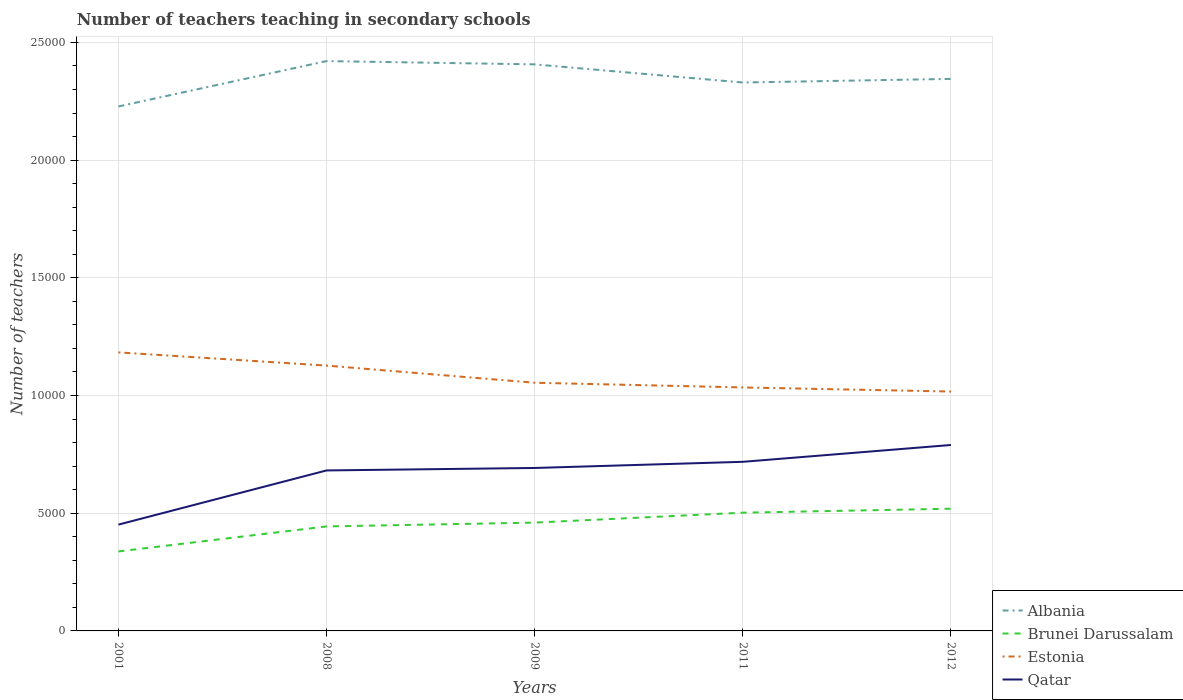How many different coloured lines are there?
Ensure brevity in your answer.  4. Does the line corresponding to Albania intersect with the line corresponding to Qatar?
Provide a short and direct response. No. Is the number of lines equal to the number of legend labels?
Your response must be concise. Yes. Across all years, what is the maximum number of teachers teaching in secondary schools in Brunei Darussalam?
Make the answer very short. 3377. What is the total number of teachers teaching in secondary schools in Qatar in the graph?
Provide a succinct answer. -366. What is the difference between the highest and the second highest number of teachers teaching in secondary schools in Brunei Darussalam?
Your response must be concise. 1815. Is the number of teachers teaching in secondary schools in Estonia strictly greater than the number of teachers teaching in secondary schools in Qatar over the years?
Give a very brief answer. No. How many years are there in the graph?
Your response must be concise. 5. What is the difference between two consecutive major ticks on the Y-axis?
Your answer should be compact. 5000. Are the values on the major ticks of Y-axis written in scientific E-notation?
Provide a short and direct response. No. Does the graph contain any zero values?
Give a very brief answer. No. What is the title of the graph?
Offer a terse response. Number of teachers teaching in secondary schools. Does "Marshall Islands" appear as one of the legend labels in the graph?
Your answer should be very brief. No. What is the label or title of the X-axis?
Ensure brevity in your answer.  Years. What is the label or title of the Y-axis?
Give a very brief answer. Number of teachers. What is the Number of teachers of Albania in 2001?
Offer a very short reply. 2.23e+04. What is the Number of teachers in Brunei Darussalam in 2001?
Provide a short and direct response. 3377. What is the Number of teachers in Estonia in 2001?
Provide a short and direct response. 1.18e+04. What is the Number of teachers in Qatar in 2001?
Your response must be concise. 4516. What is the Number of teachers in Albania in 2008?
Provide a succinct answer. 2.42e+04. What is the Number of teachers of Brunei Darussalam in 2008?
Your response must be concise. 4439. What is the Number of teachers in Estonia in 2008?
Provide a short and direct response. 1.13e+04. What is the Number of teachers in Qatar in 2008?
Provide a short and direct response. 6818. What is the Number of teachers in Albania in 2009?
Ensure brevity in your answer.  2.41e+04. What is the Number of teachers of Brunei Darussalam in 2009?
Offer a terse response. 4601. What is the Number of teachers in Estonia in 2009?
Your answer should be compact. 1.05e+04. What is the Number of teachers in Qatar in 2009?
Offer a very short reply. 6923. What is the Number of teachers in Albania in 2011?
Offer a terse response. 2.33e+04. What is the Number of teachers in Brunei Darussalam in 2011?
Provide a succinct answer. 5023. What is the Number of teachers of Estonia in 2011?
Make the answer very short. 1.03e+04. What is the Number of teachers in Qatar in 2011?
Ensure brevity in your answer.  7184. What is the Number of teachers of Albania in 2012?
Ensure brevity in your answer.  2.35e+04. What is the Number of teachers in Brunei Darussalam in 2012?
Provide a succinct answer. 5192. What is the Number of teachers in Estonia in 2012?
Your answer should be compact. 1.02e+04. What is the Number of teachers in Qatar in 2012?
Provide a short and direct response. 7899. Across all years, what is the maximum Number of teachers of Albania?
Make the answer very short. 2.42e+04. Across all years, what is the maximum Number of teachers in Brunei Darussalam?
Provide a succinct answer. 5192. Across all years, what is the maximum Number of teachers of Estonia?
Make the answer very short. 1.18e+04. Across all years, what is the maximum Number of teachers of Qatar?
Your answer should be compact. 7899. Across all years, what is the minimum Number of teachers of Albania?
Make the answer very short. 2.23e+04. Across all years, what is the minimum Number of teachers of Brunei Darussalam?
Keep it short and to the point. 3377. Across all years, what is the minimum Number of teachers of Estonia?
Keep it short and to the point. 1.02e+04. Across all years, what is the minimum Number of teachers in Qatar?
Provide a succinct answer. 4516. What is the total Number of teachers in Albania in the graph?
Offer a very short reply. 1.17e+05. What is the total Number of teachers of Brunei Darussalam in the graph?
Your answer should be compact. 2.26e+04. What is the total Number of teachers of Estonia in the graph?
Give a very brief answer. 5.42e+04. What is the total Number of teachers in Qatar in the graph?
Your answer should be very brief. 3.33e+04. What is the difference between the Number of teachers in Albania in 2001 and that in 2008?
Keep it short and to the point. -1928. What is the difference between the Number of teachers in Brunei Darussalam in 2001 and that in 2008?
Make the answer very short. -1062. What is the difference between the Number of teachers of Estonia in 2001 and that in 2008?
Ensure brevity in your answer.  561. What is the difference between the Number of teachers in Qatar in 2001 and that in 2008?
Make the answer very short. -2302. What is the difference between the Number of teachers in Albania in 2001 and that in 2009?
Give a very brief answer. -1789. What is the difference between the Number of teachers in Brunei Darussalam in 2001 and that in 2009?
Your response must be concise. -1224. What is the difference between the Number of teachers in Estonia in 2001 and that in 2009?
Provide a succinct answer. 1290. What is the difference between the Number of teachers in Qatar in 2001 and that in 2009?
Provide a short and direct response. -2407. What is the difference between the Number of teachers of Albania in 2001 and that in 2011?
Your answer should be compact. -1018. What is the difference between the Number of teachers of Brunei Darussalam in 2001 and that in 2011?
Your answer should be compact. -1646. What is the difference between the Number of teachers in Estonia in 2001 and that in 2011?
Provide a succinct answer. 1489. What is the difference between the Number of teachers in Qatar in 2001 and that in 2011?
Ensure brevity in your answer.  -2668. What is the difference between the Number of teachers in Albania in 2001 and that in 2012?
Keep it short and to the point. -1172. What is the difference between the Number of teachers of Brunei Darussalam in 2001 and that in 2012?
Provide a succinct answer. -1815. What is the difference between the Number of teachers of Estonia in 2001 and that in 2012?
Give a very brief answer. 1663. What is the difference between the Number of teachers of Qatar in 2001 and that in 2012?
Offer a very short reply. -3383. What is the difference between the Number of teachers in Albania in 2008 and that in 2009?
Give a very brief answer. 139. What is the difference between the Number of teachers in Brunei Darussalam in 2008 and that in 2009?
Provide a succinct answer. -162. What is the difference between the Number of teachers of Estonia in 2008 and that in 2009?
Keep it short and to the point. 729. What is the difference between the Number of teachers of Qatar in 2008 and that in 2009?
Provide a short and direct response. -105. What is the difference between the Number of teachers in Albania in 2008 and that in 2011?
Provide a short and direct response. 910. What is the difference between the Number of teachers in Brunei Darussalam in 2008 and that in 2011?
Your answer should be very brief. -584. What is the difference between the Number of teachers of Estonia in 2008 and that in 2011?
Your response must be concise. 928. What is the difference between the Number of teachers of Qatar in 2008 and that in 2011?
Your answer should be compact. -366. What is the difference between the Number of teachers in Albania in 2008 and that in 2012?
Give a very brief answer. 756. What is the difference between the Number of teachers of Brunei Darussalam in 2008 and that in 2012?
Offer a terse response. -753. What is the difference between the Number of teachers of Estonia in 2008 and that in 2012?
Keep it short and to the point. 1102. What is the difference between the Number of teachers of Qatar in 2008 and that in 2012?
Your answer should be compact. -1081. What is the difference between the Number of teachers of Albania in 2009 and that in 2011?
Offer a very short reply. 771. What is the difference between the Number of teachers in Brunei Darussalam in 2009 and that in 2011?
Make the answer very short. -422. What is the difference between the Number of teachers in Estonia in 2009 and that in 2011?
Give a very brief answer. 199. What is the difference between the Number of teachers of Qatar in 2009 and that in 2011?
Your answer should be compact. -261. What is the difference between the Number of teachers of Albania in 2009 and that in 2012?
Your answer should be very brief. 617. What is the difference between the Number of teachers of Brunei Darussalam in 2009 and that in 2012?
Provide a short and direct response. -591. What is the difference between the Number of teachers in Estonia in 2009 and that in 2012?
Ensure brevity in your answer.  373. What is the difference between the Number of teachers in Qatar in 2009 and that in 2012?
Your answer should be very brief. -976. What is the difference between the Number of teachers in Albania in 2011 and that in 2012?
Provide a short and direct response. -154. What is the difference between the Number of teachers of Brunei Darussalam in 2011 and that in 2012?
Offer a very short reply. -169. What is the difference between the Number of teachers in Estonia in 2011 and that in 2012?
Provide a short and direct response. 174. What is the difference between the Number of teachers of Qatar in 2011 and that in 2012?
Your answer should be compact. -715. What is the difference between the Number of teachers of Albania in 2001 and the Number of teachers of Brunei Darussalam in 2008?
Keep it short and to the point. 1.78e+04. What is the difference between the Number of teachers of Albania in 2001 and the Number of teachers of Estonia in 2008?
Your answer should be very brief. 1.10e+04. What is the difference between the Number of teachers of Albania in 2001 and the Number of teachers of Qatar in 2008?
Offer a terse response. 1.55e+04. What is the difference between the Number of teachers in Brunei Darussalam in 2001 and the Number of teachers in Estonia in 2008?
Offer a very short reply. -7895. What is the difference between the Number of teachers in Brunei Darussalam in 2001 and the Number of teachers in Qatar in 2008?
Provide a short and direct response. -3441. What is the difference between the Number of teachers in Estonia in 2001 and the Number of teachers in Qatar in 2008?
Provide a succinct answer. 5015. What is the difference between the Number of teachers in Albania in 2001 and the Number of teachers in Brunei Darussalam in 2009?
Your response must be concise. 1.77e+04. What is the difference between the Number of teachers in Albania in 2001 and the Number of teachers in Estonia in 2009?
Ensure brevity in your answer.  1.17e+04. What is the difference between the Number of teachers in Albania in 2001 and the Number of teachers in Qatar in 2009?
Ensure brevity in your answer.  1.54e+04. What is the difference between the Number of teachers in Brunei Darussalam in 2001 and the Number of teachers in Estonia in 2009?
Provide a succinct answer. -7166. What is the difference between the Number of teachers of Brunei Darussalam in 2001 and the Number of teachers of Qatar in 2009?
Make the answer very short. -3546. What is the difference between the Number of teachers of Estonia in 2001 and the Number of teachers of Qatar in 2009?
Provide a short and direct response. 4910. What is the difference between the Number of teachers in Albania in 2001 and the Number of teachers in Brunei Darussalam in 2011?
Offer a terse response. 1.73e+04. What is the difference between the Number of teachers in Albania in 2001 and the Number of teachers in Estonia in 2011?
Your response must be concise. 1.19e+04. What is the difference between the Number of teachers of Albania in 2001 and the Number of teachers of Qatar in 2011?
Your response must be concise. 1.51e+04. What is the difference between the Number of teachers of Brunei Darussalam in 2001 and the Number of teachers of Estonia in 2011?
Make the answer very short. -6967. What is the difference between the Number of teachers of Brunei Darussalam in 2001 and the Number of teachers of Qatar in 2011?
Make the answer very short. -3807. What is the difference between the Number of teachers in Estonia in 2001 and the Number of teachers in Qatar in 2011?
Give a very brief answer. 4649. What is the difference between the Number of teachers in Albania in 2001 and the Number of teachers in Brunei Darussalam in 2012?
Provide a succinct answer. 1.71e+04. What is the difference between the Number of teachers in Albania in 2001 and the Number of teachers in Estonia in 2012?
Provide a short and direct response. 1.21e+04. What is the difference between the Number of teachers in Albania in 2001 and the Number of teachers in Qatar in 2012?
Make the answer very short. 1.44e+04. What is the difference between the Number of teachers in Brunei Darussalam in 2001 and the Number of teachers in Estonia in 2012?
Provide a short and direct response. -6793. What is the difference between the Number of teachers of Brunei Darussalam in 2001 and the Number of teachers of Qatar in 2012?
Offer a terse response. -4522. What is the difference between the Number of teachers of Estonia in 2001 and the Number of teachers of Qatar in 2012?
Your response must be concise. 3934. What is the difference between the Number of teachers of Albania in 2008 and the Number of teachers of Brunei Darussalam in 2009?
Your answer should be compact. 1.96e+04. What is the difference between the Number of teachers of Albania in 2008 and the Number of teachers of Estonia in 2009?
Provide a succinct answer. 1.37e+04. What is the difference between the Number of teachers in Albania in 2008 and the Number of teachers in Qatar in 2009?
Offer a very short reply. 1.73e+04. What is the difference between the Number of teachers of Brunei Darussalam in 2008 and the Number of teachers of Estonia in 2009?
Ensure brevity in your answer.  -6104. What is the difference between the Number of teachers in Brunei Darussalam in 2008 and the Number of teachers in Qatar in 2009?
Your answer should be compact. -2484. What is the difference between the Number of teachers in Estonia in 2008 and the Number of teachers in Qatar in 2009?
Make the answer very short. 4349. What is the difference between the Number of teachers in Albania in 2008 and the Number of teachers in Brunei Darussalam in 2011?
Give a very brief answer. 1.92e+04. What is the difference between the Number of teachers in Albania in 2008 and the Number of teachers in Estonia in 2011?
Your answer should be compact. 1.39e+04. What is the difference between the Number of teachers of Albania in 2008 and the Number of teachers of Qatar in 2011?
Make the answer very short. 1.70e+04. What is the difference between the Number of teachers in Brunei Darussalam in 2008 and the Number of teachers in Estonia in 2011?
Offer a very short reply. -5905. What is the difference between the Number of teachers of Brunei Darussalam in 2008 and the Number of teachers of Qatar in 2011?
Ensure brevity in your answer.  -2745. What is the difference between the Number of teachers in Estonia in 2008 and the Number of teachers in Qatar in 2011?
Provide a succinct answer. 4088. What is the difference between the Number of teachers in Albania in 2008 and the Number of teachers in Brunei Darussalam in 2012?
Offer a terse response. 1.90e+04. What is the difference between the Number of teachers of Albania in 2008 and the Number of teachers of Estonia in 2012?
Ensure brevity in your answer.  1.40e+04. What is the difference between the Number of teachers in Albania in 2008 and the Number of teachers in Qatar in 2012?
Ensure brevity in your answer.  1.63e+04. What is the difference between the Number of teachers of Brunei Darussalam in 2008 and the Number of teachers of Estonia in 2012?
Offer a terse response. -5731. What is the difference between the Number of teachers in Brunei Darussalam in 2008 and the Number of teachers in Qatar in 2012?
Give a very brief answer. -3460. What is the difference between the Number of teachers in Estonia in 2008 and the Number of teachers in Qatar in 2012?
Ensure brevity in your answer.  3373. What is the difference between the Number of teachers in Albania in 2009 and the Number of teachers in Brunei Darussalam in 2011?
Your response must be concise. 1.90e+04. What is the difference between the Number of teachers of Albania in 2009 and the Number of teachers of Estonia in 2011?
Ensure brevity in your answer.  1.37e+04. What is the difference between the Number of teachers in Albania in 2009 and the Number of teachers in Qatar in 2011?
Ensure brevity in your answer.  1.69e+04. What is the difference between the Number of teachers in Brunei Darussalam in 2009 and the Number of teachers in Estonia in 2011?
Keep it short and to the point. -5743. What is the difference between the Number of teachers of Brunei Darussalam in 2009 and the Number of teachers of Qatar in 2011?
Offer a very short reply. -2583. What is the difference between the Number of teachers in Estonia in 2009 and the Number of teachers in Qatar in 2011?
Provide a succinct answer. 3359. What is the difference between the Number of teachers in Albania in 2009 and the Number of teachers in Brunei Darussalam in 2012?
Provide a short and direct response. 1.89e+04. What is the difference between the Number of teachers of Albania in 2009 and the Number of teachers of Estonia in 2012?
Your response must be concise. 1.39e+04. What is the difference between the Number of teachers of Albania in 2009 and the Number of teachers of Qatar in 2012?
Make the answer very short. 1.62e+04. What is the difference between the Number of teachers in Brunei Darussalam in 2009 and the Number of teachers in Estonia in 2012?
Offer a terse response. -5569. What is the difference between the Number of teachers in Brunei Darussalam in 2009 and the Number of teachers in Qatar in 2012?
Give a very brief answer. -3298. What is the difference between the Number of teachers of Estonia in 2009 and the Number of teachers of Qatar in 2012?
Ensure brevity in your answer.  2644. What is the difference between the Number of teachers in Albania in 2011 and the Number of teachers in Brunei Darussalam in 2012?
Your response must be concise. 1.81e+04. What is the difference between the Number of teachers in Albania in 2011 and the Number of teachers in Estonia in 2012?
Ensure brevity in your answer.  1.31e+04. What is the difference between the Number of teachers in Albania in 2011 and the Number of teachers in Qatar in 2012?
Give a very brief answer. 1.54e+04. What is the difference between the Number of teachers in Brunei Darussalam in 2011 and the Number of teachers in Estonia in 2012?
Ensure brevity in your answer.  -5147. What is the difference between the Number of teachers of Brunei Darussalam in 2011 and the Number of teachers of Qatar in 2012?
Provide a short and direct response. -2876. What is the difference between the Number of teachers of Estonia in 2011 and the Number of teachers of Qatar in 2012?
Make the answer very short. 2445. What is the average Number of teachers of Albania per year?
Your answer should be compact. 2.35e+04. What is the average Number of teachers in Brunei Darussalam per year?
Offer a very short reply. 4526.4. What is the average Number of teachers of Estonia per year?
Ensure brevity in your answer.  1.08e+04. What is the average Number of teachers of Qatar per year?
Make the answer very short. 6668. In the year 2001, what is the difference between the Number of teachers in Albania and Number of teachers in Brunei Darussalam?
Give a very brief answer. 1.89e+04. In the year 2001, what is the difference between the Number of teachers in Albania and Number of teachers in Estonia?
Your answer should be very brief. 1.04e+04. In the year 2001, what is the difference between the Number of teachers in Albania and Number of teachers in Qatar?
Give a very brief answer. 1.78e+04. In the year 2001, what is the difference between the Number of teachers in Brunei Darussalam and Number of teachers in Estonia?
Your answer should be compact. -8456. In the year 2001, what is the difference between the Number of teachers of Brunei Darussalam and Number of teachers of Qatar?
Give a very brief answer. -1139. In the year 2001, what is the difference between the Number of teachers of Estonia and Number of teachers of Qatar?
Give a very brief answer. 7317. In the year 2008, what is the difference between the Number of teachers of Albania and Number of teachers of Brunei Darussalam?
Offer a very short reply. 1.98e+04. In the year 2008, what is the difference between the Number of teachers in Albania and Number of teachers in Estonia?
Keep it short and to the point. 1.29e+04. In the year 2008, what is the difference between the Number of teachers in Albania and Number of teachers in Qatar?
Make the answer very short. 1.74e+04. In the year 2008, what is the difference between the Number of teachers in Brunei Darussalam and Number of teachers in Estonia?
Your answer should be very brief. -6833. In the year 2008, what is the difference between the Number of teachers in Brunei Darussalam and Number of teachers in Qatar?
Offer a very short reply. -2379. In the year 2008, what is the difference between the Number of teachers of Estonia and Number of teachers of Qatar?
Give a very brief answer. 4454. In the year 2009, what is the difference between the Number of teachers of Albania and Number of teachers of Brunei Darussalam?
Keep it short and to the point. 1.95e+04. In the year 2009, what is the difference between the Number of teachers of Albania and Number of teachers of Estonia?
Your answer should be compact. 1.35e+04. In the year 2009, what is the difference between the Number of teachers in Albania and Number of teachers in Qatar?
Ensure brevity in your answer.  1.71e+04. In the year 2009, what is the difference between the Number of teachers in Brunei Darussalam and Number of teachers in Estonia?
Your answer should be compact. -5942. In the year 2009, what is the difference between the Number of teachers of Brunei Darussalam and Number of teachers of Qatar?
Provide a short and direct response. -2322. In the year 2009, what is the difference between the Number of teachers in Estonia and Number of teachers in Qatar?
Keep it short and to the point. 3620. In the year 2011, what is the difference between the Number of teachers in Albania and Number of teachers in Brunei Darussalam?
Your answer should be very brief. 1.83e+04. In the year 2011, what is the difference between the Number of teachers in Albania and Number of teachers in Estonia?
Offer a very short reply. 1.30e+04. In the year 2011, what is the difference between the Number of teachers in Albania and Number of teachers in Qatar?
Your answer should be compact. 1.61e+04. In the year 2011, what is the difference between the Number of teachers of Brunei Darussalam and Number of teachers of Estonia?
Make the answer very short. -5321. In the year 2011, what is the difference between the Number of teachers in Brunei Darussalam and Number of teachers in Qatar?
Give a very brief answer. -2161. In the year 2011, what is the difference between the Number of teachers of Estonia and Number of teachers of Qatar?
Your answer should be compact. 3160. In the year 2012, what is the difference between the Number of teachers of Albania and Number of teachers of Brunei Darussalam?
Give a very brief answer. 1.83e+04. In the year 2012, what is the difference between the Number of teachers of Albania and Number of teachers of Estonia?
Give a very brief answer. 1.33e+04. In the year 2012, what is the difference between the Number of teachers in Albania and Number of teachers in Qatar?
Your answer should be compact. 1.56e+04. In the year 2012, what is the difference between the Number of teachers in Brunei Darussalam and Number of teachers in Estonia?
Your answer should be compact. -4978. In the year 2012, what is the difference between the Number of teachers in Brunei Darussalam and Number of teachers in Qatar?
Give a very brief answer. -2707. In the year 2012, what is the difference between the Number of teachers in Estonia and Number of teachers in Qatar?
Your answer should be very brief. 2271. What is the ratio of the Number of teachers in Albania in 2001 to that in 2008?
Provide a succinct answer. 0.92. What is the ratio of the Number of teachers of Brunei Darussalam in 2001 to that in 2008?
Offer a very short reply. 0.76. What is the ratio of the Number of teachers in Estonia in 2001 to that in 2008?
Make the answer very short. 1.05. What is the ratio of the Number of teachers in Qatar in 2001 to that in 2008?
Give a very brief answer. 0.66. What is the ratio of the Number of teachers in Albania in 2001 to that in 2009?
Make the answer very short. 0.93. What is the ratio of the Number of teachers in Brunei Darussalam in 2001 to that in 2009?
Your answer should be compact. 0.73. What is the ratio of the Number of teachers of Estonia in 2001 to that in 2009?
Offer a terse response. 1.12. What is the ratio of the Number of teachers of Qatar in 2001 to that in 2009?
Ensure brevity in your answer.  0.65. What is the ratio of the Number of teachers in Albania in 2001 to that in 2011?
Provide a short and direct response. 0.96. What is the ratio of the Number of teachers of Brunei Darussalam in 2001 to that in 2011?
Keep it short and to the point. 0.67. What is the ratio of the Number of teachers in Estonia in 2001 to that in 2011?
Keep it short and to the point. 1.14. What is the ratio of the Number of teachers of Qatar in 2001 to that in 2011?
Your response must be concise. 0.63. What is the ratio of the Number of teachers in Albania in 2001 to that in 2012?
Your answer should be very brief. 0.95. What is the ratio of the Number of teachers of Brunei Darussalam in 2001 to that in 2012?
Make the answer very short. 0.65. What is the ratio of the Number of teachers in Estonia in 2001 to that in 2012?
Offer a very short reply. 1.16. What is the ratio of the Number of teachers in Qatar in 2001 to that in 2012?
Ensure brevity in your answer.  0.57. What is the ratio of the Number of teachers of Albania in 2008 to that in 2009?
Your answer should be compact. 1.01. What is the ratio of the Number of teachers of Brunei Darussalam in 2008 to that in 2009?
Your response must be concise. 0.96. What is the ratio of the Number of teachers in Estonia in 2008 to that in 2009?
Make the answer very short. 1.07. What is the ratio of the Number of teachers of Albania in 2008 to that in 2011?
Provide a short and direct response. 1.04. What is the ratio of the Number of teachers of Brunei Darussalam in 2008 to that in 2011?
Offer a very short reply. 0.88. What is the ratio of the Number of teachers of Estonia in 2008 to that in 2011?
Ensure brevity in your answer.  1.09. What is the ratio of the Number of teachers in Qatar in 2008 to that in 2011?
Provide a succinct answer. 0.95. What is the ratio of the Number of teachers of Albania in 2008 to that in 2012?
Offer a terse response. 1.03. What is the ratio of the Number of teachers in Brunei Darussalam in 2008 to that in 2012?
Make the answer very short. 0.85. What is the ratio of the Number of teachers in Estonia in 2008 to that in 2012?
Keep it short and to the point. 1.11. What is the ratio of the Number of teachers in Qatar in 2008 to that in 2012?
Make the answer very short. 0.86. What is the ratio of the Number of teachers in Albania in 2009 to that in 2011?
Keep it short and to the point. 1.03. What is the ratio of the Number of teachers in Brunei Darussalam in 2009 to that in 2011?
Your answer should be very brief. 0.92. What is the ratio of the Number of teachers in Estonia in 2009 to that in 2011?
Your response must be concise. 1.02. What is the ratio of the Number of teachers in Qatar in 2009 to that in 2011?
Your answer should be compact. 0.96. What is the ratio of the Number of teachers of Albania in 2009 to that in 2012?
Offer a very short reply. 1.03. What is the ratio of the Number of teachers in Brunei Darussalam in 2009 to that in 2012?
Your answer should be compact. 0.89. What is the ratio of the Number of teachers of Estonia in 2009 to that in 2012?
Your answer should be compact. 1.04. What is the ratio of the Number of teachers in Qatar in 2009 to that in 2012?
Provide a succinct answer. 0.88. What is the ratio of the Number of teachers of Brunei Darussalam in 2011 to that in 2012?
Your response must be concise. 0.97. What is the ratio of the Number of teachers in Estonia in 2011 to that in 2012?
Your response must be concise. 1.02. What is the ratio of the Number of teachers of Qatar in 2011 to that in 2012?
Offer a terse response. 0.91. What is the difference between the highest and the second highest Number of teachers in Albania?
Provide a succinct answer. 139. What is the difference between the highest and the second highest Number of teachers of Brunei Darussalam?
Your response must be concise. 169. What is the difference between the highest and the second highest Number of teachers of Estonia?
Keep it short and to the point. 561. What is the difference between the highest and the second highest Number of teachers in Qatar?
Provide a succinct answer. 715. What is the difference between the highest and the lowest Number of teachers of Albania?
Ensure brevity in your answer.  1928. What is the difference between the highest and the lowest Number of teachers of Brunei Darussalam?
Keep it short and to the point. 1815. What is the difference between the highest and the lowest Number of teachers of Estonia?
Keep it short and to the point. 1663. What is the difference between the highest and the lowest Number of teachers of Qatar?
Offer a very short reply. 3383. 